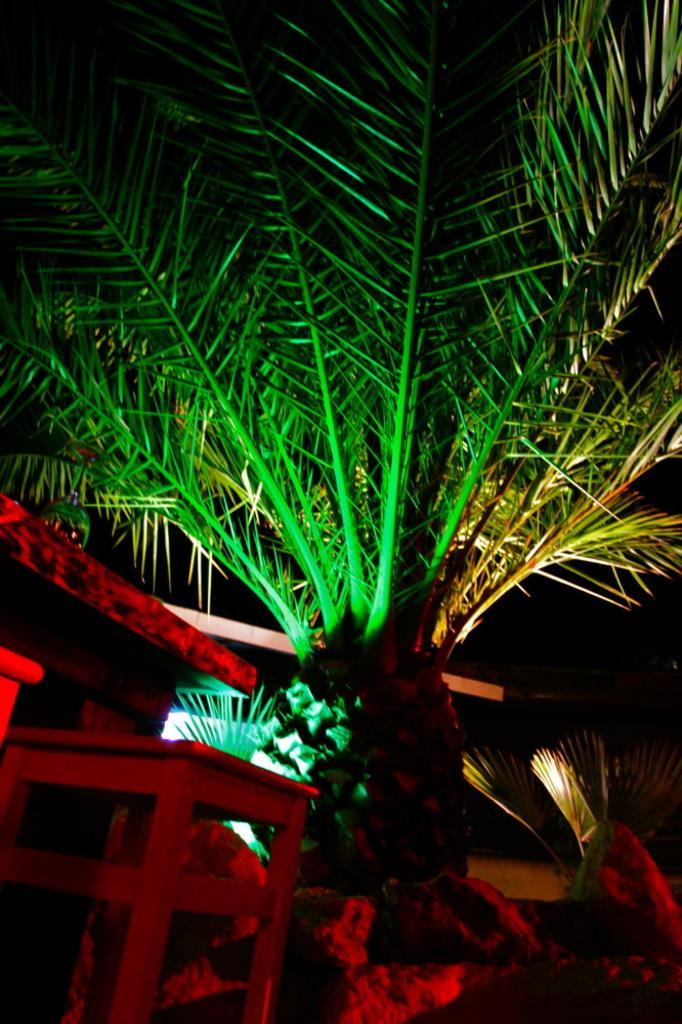What type of furniture is present in the image? There is a table in the image. What type of vegetation can be seen in the image? There are plants and trees in the image. What type of badge is hanging from the tree in the image? There is no badge present in the image; it only features a table, plants, and trees. How many bags can be seen on the table in the image? There are no bags present on the table in the image. 